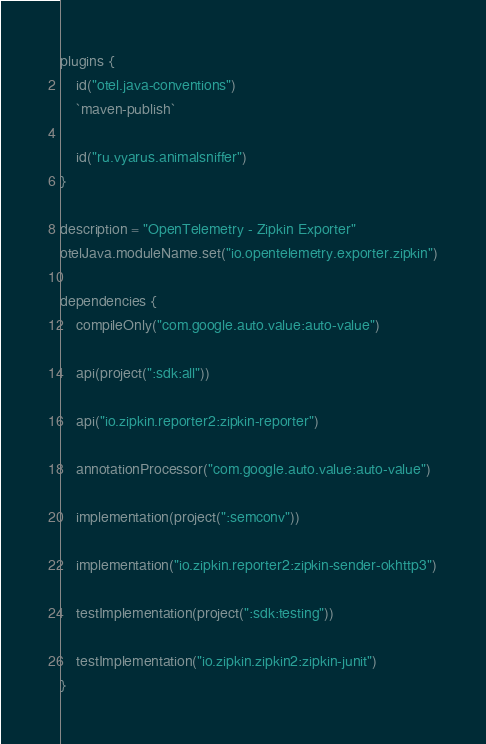<code> <loc_0><loc_0><loc_500><loc_500><_Kotlin_>plugins {
    id("otel.java-conventions")
    `maven-publish`

    id("ru.vyarus.animalsniffer")
}

description = "OpenTelemetry - Zipkin Exporter"
otelJava.moduleName.set("io.opentelemetry.exporter.zipkin")

dependencies {
    compileOnly("com.google.auto.value:auto-value")

    api(project(":sdk:all"))

    api("io.zipkin.reporter2:zipkin-reporter")

    annotationProcessor("com.google.auto.value:auto-value")

    implementation(project(":semconv"))

    implementation("io.zipkin.reporter2:zipkin-sender-okhttp3")

    testImplementation(project(":sdk:testing"))

    testImplementation("io.zipkin.zipkin2:zipkin-junit")
}
</code> 